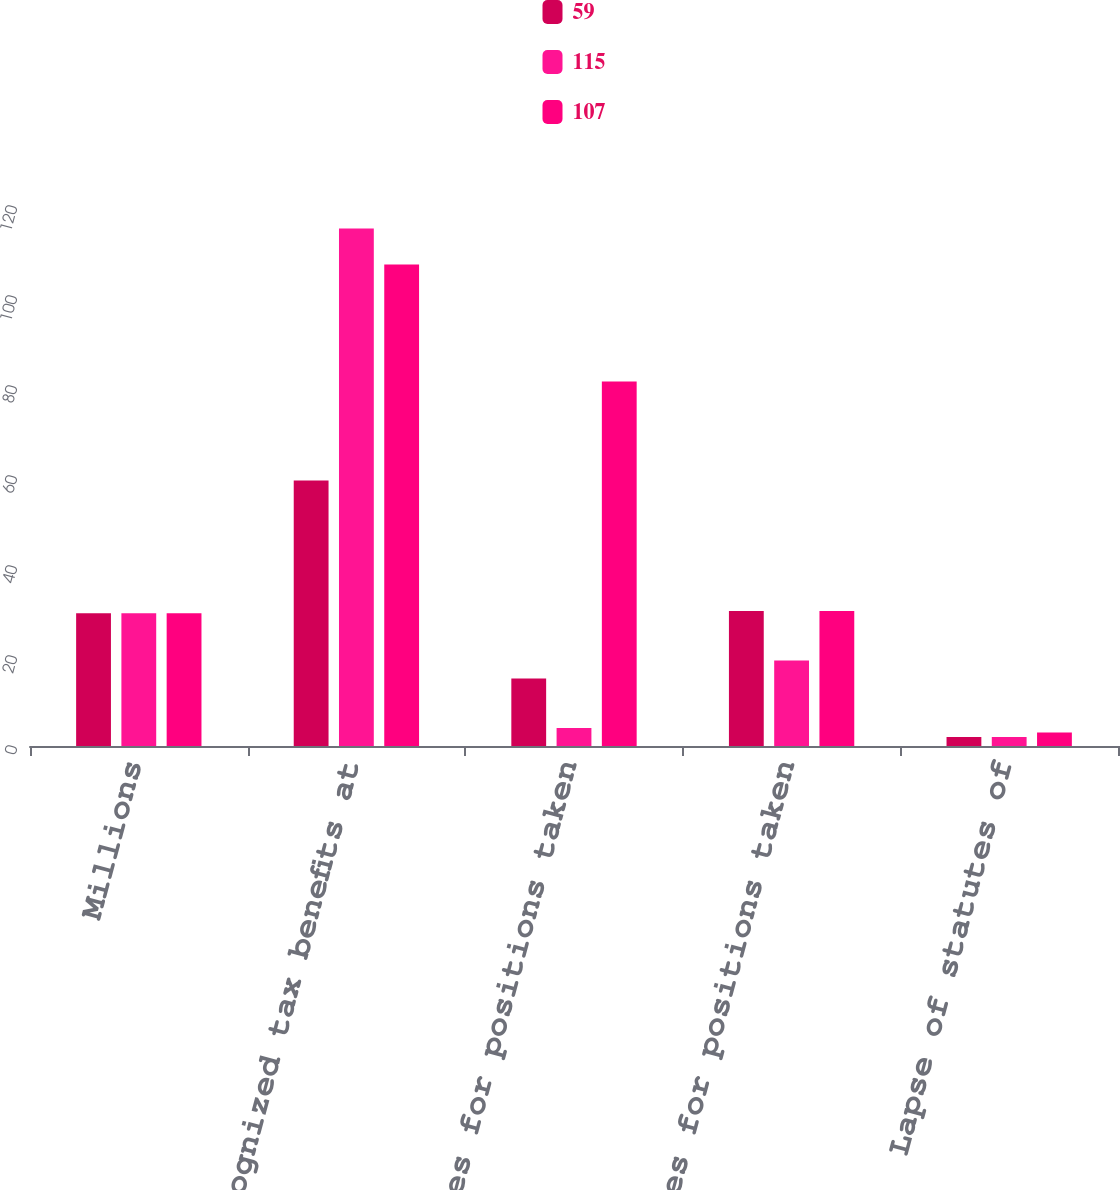<chart> <loc_0><loc_0><loc_500><loc_500><stacked_bar_chart><ecel><fcel>Millions<fcel>Unrecognized tax benefits at<fcel>Increases for positions taken<fcel>Decreases for positions taken<fcel>Lapse of statutes of<nl><fcel>59<fcel>29.5<fcel>59<fcel>15<fcel>30<fcel>2<nl><fcel>115<fcel>29.5<fcel>115<fcel>4<fcel>19<fcel>2<nl><fcel>107<fcel>29.5<fcel>107<fcel>81<fcel>30<fcel>3<nl></chart> 